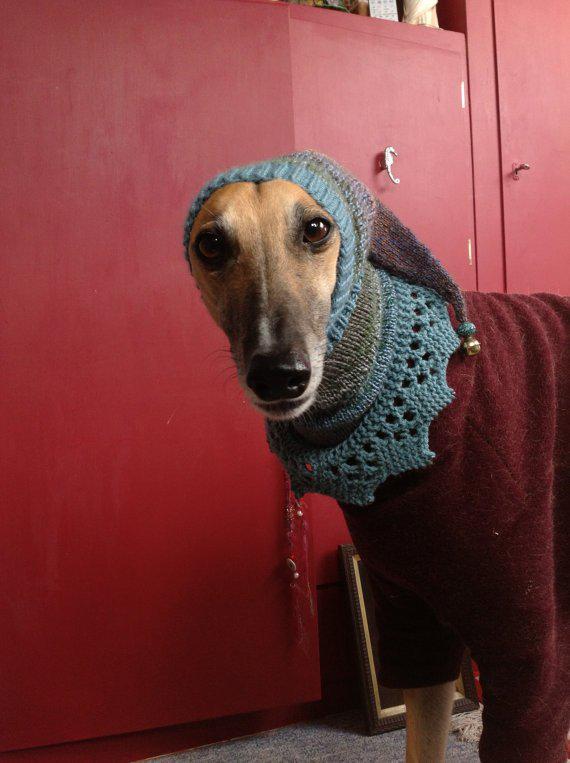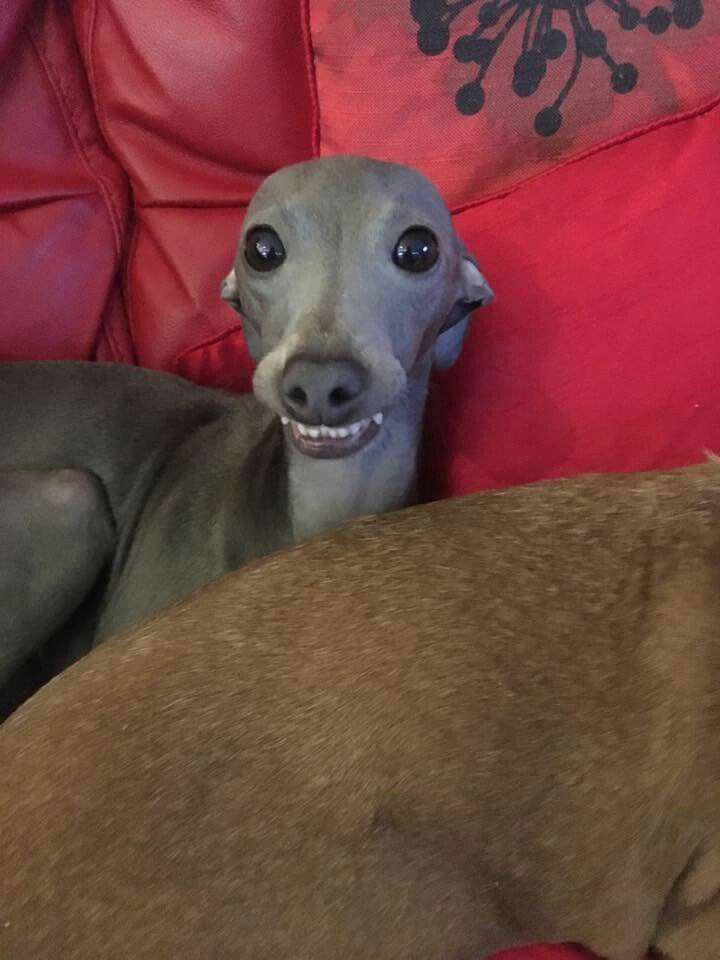The first image is the image on the left, the second image is the image on the right. Considering the images on both sides, is "One image shows a mostly light brown dog standing on all fours in the grass." valid? Answer yes or no. No. The first image is the image on the left, the second image is the image on the right. For the images shown, is this caption "One of the dogs is resting on a couch." true? Answer yes or no. Yes. 